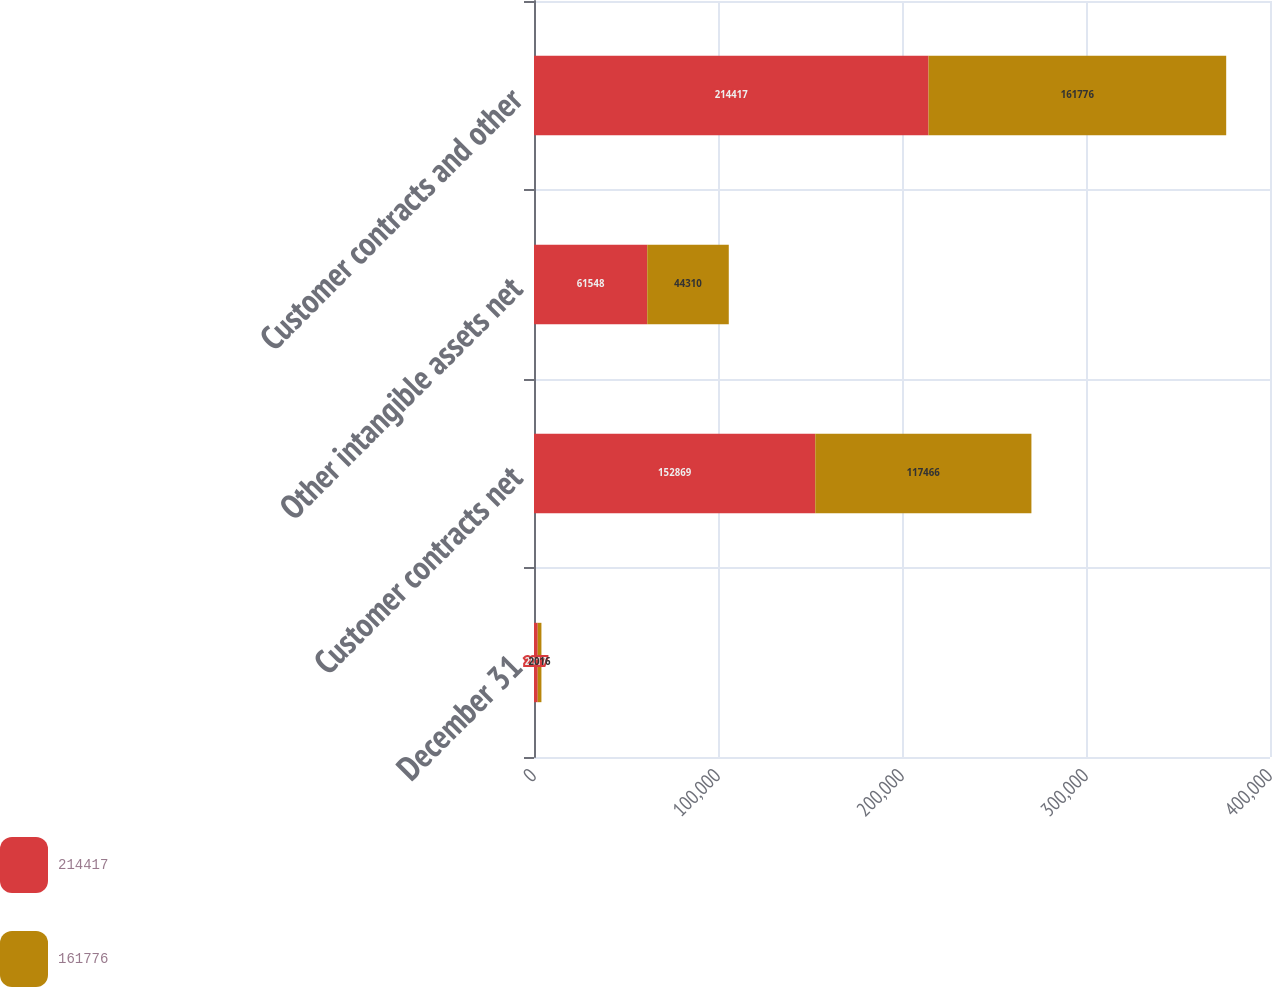Convert chart. <chart><loc_0><loc_0><loc_500><loc_500><stacked_bar_chart><ecel><fcel>December 31<fcel>Customer contracts net<fcel>Other intangible assets net<fcel>Customer contracts and other<nl><fcel>214417<fcel>2017<fcel>152869<fcel>61548<fcel>214417<nl><fcel>161776<fcel>2016<fcel>117466<fcel>44310<fcel>161776<nl></chart> 